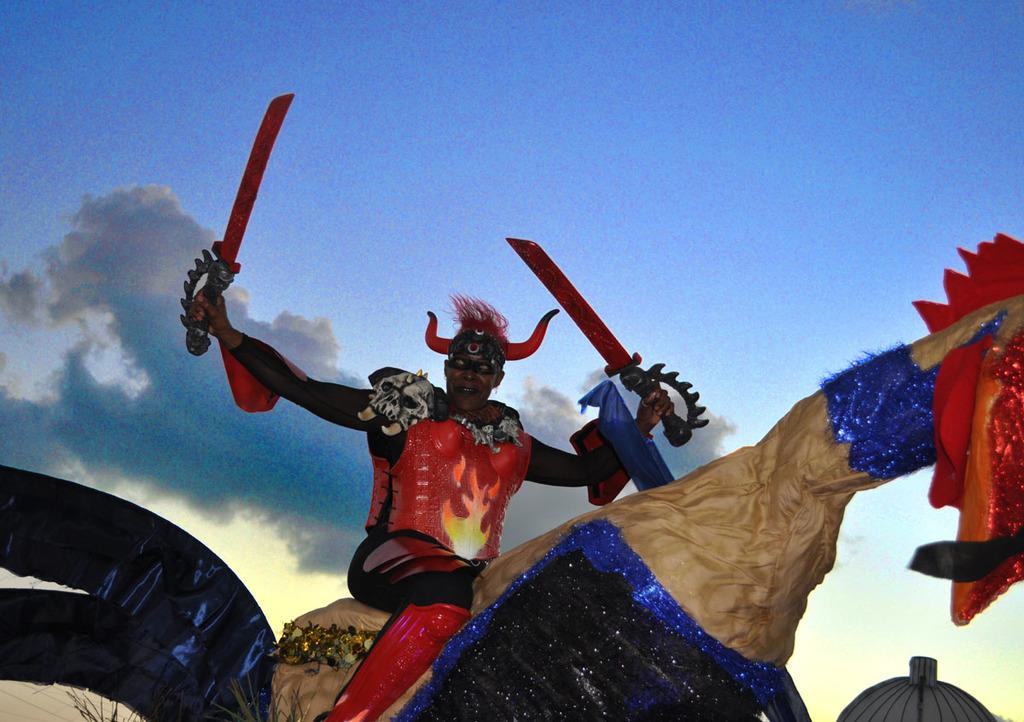Who or what is present in the image? There is a person in the image. What is the person doing in the image? The person is sitting on an object and holding swords in their hands. What can be seen in the background of the image? There is an object in the background of the image, and there are clouds in the sky. What type of smoke can be seen coming from the swords in the image? There is no smoke present in the image; the swords are not on fire or producing any smoke. 